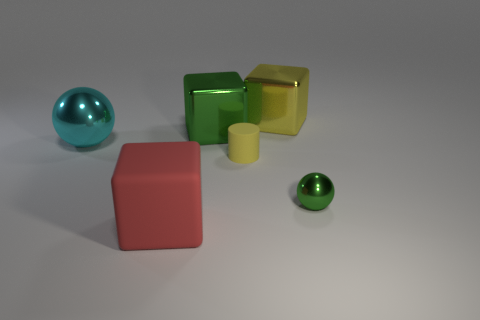Subtract all large red rubber blocks. How many blocks are left? 2 Add 3 yellow cylinders. How many objects exist? 9 Subtract all red cubes. How many cubes are left? 2 Subtract all balls. How many objects are left? 4 Subtract 1 cylinders. How many cylinders are left? 0 Subtract all purple balls. Subtract all red blocks. How many balls are left? 2 Subtract all red cylinders. How many blue balls are left? 0 Subtract all cyan metallic objects. Subtract all cyan cubes. How many objects are left? 5 Add 2 green shiny spheres. How many green shiny spheres are left? 3 Add 5 small matte objects. How many small matte objects exist? 6 